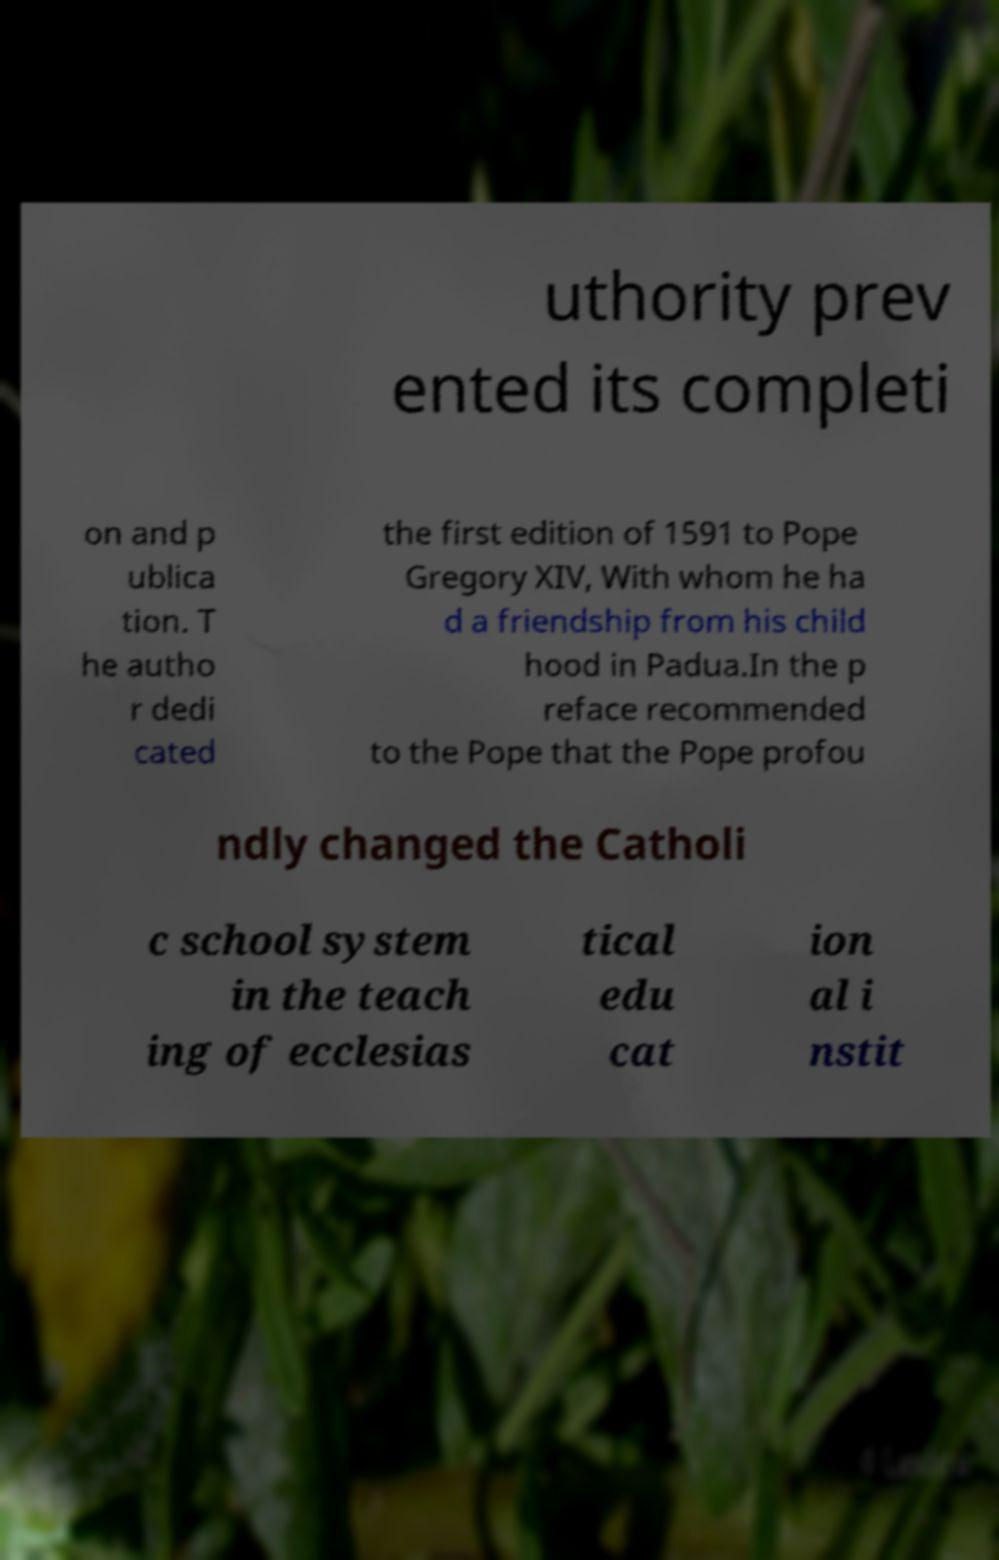Could you assist in decoding the text presented in this image and type it out clearly? uthority prev ented its completi on and p ublica tion. T he autho r dedi cated the first edition of 1591 to Pope Gregory XIV, With whom he ha d a friendship from his child hood in Padua.In the p reface recommended to the Pope that the Pope profou ndly changed the Catholi c school system in the teach ing of ecclesias tical edu cat ion al i nstit 